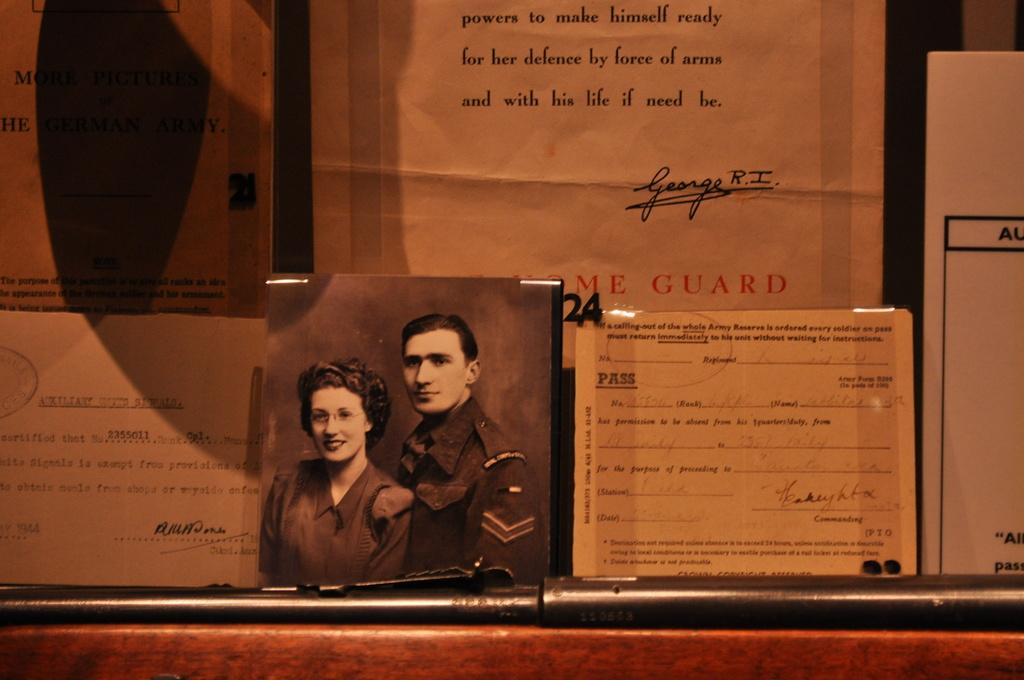What type of paper is present in the image? There are notice papers in the image. What is written on the notice papers? The notice papers contain text. Who are the people in the image? There is a woman and a man in the image. What type of vegetable is being used as a pencil in the image? There is no vegetable being used as a pencil in the image. What sound can be heard in the image due to thunder? There is no thunder or sound present in the image. 